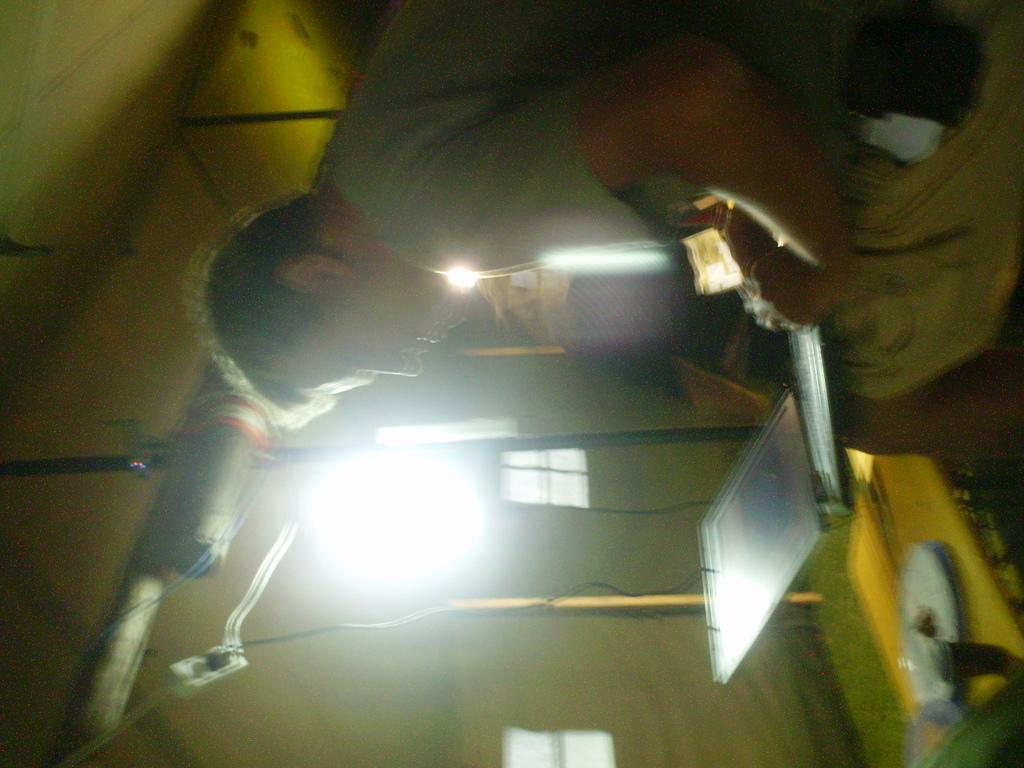Please provide a concise description of this image. In this image I can see a person is sitting and holding a laptop in his lap. In the background I can see a light, a black colored rod, few wires, a yellow colored tent, few window of the tent and I can see a yellow colored object on which I can see a plate, a cup and few other objects. 